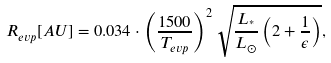Convert formula to latex. <formula><loc_0><loc_0><loc_500><loc_500>R _ { e v p } [ A U ] = 0 . 0 3 4 \cdot \left ( \frac { 1 5 0 0 } { T _ { e v p } } \right ) ^ { 2 } \sqrt { \frac { L _ { ^ { * } } } { L _ { \odot } } \left ( 2 + \frac { 1 } { \epsilon } \right ) } ,</formula> 